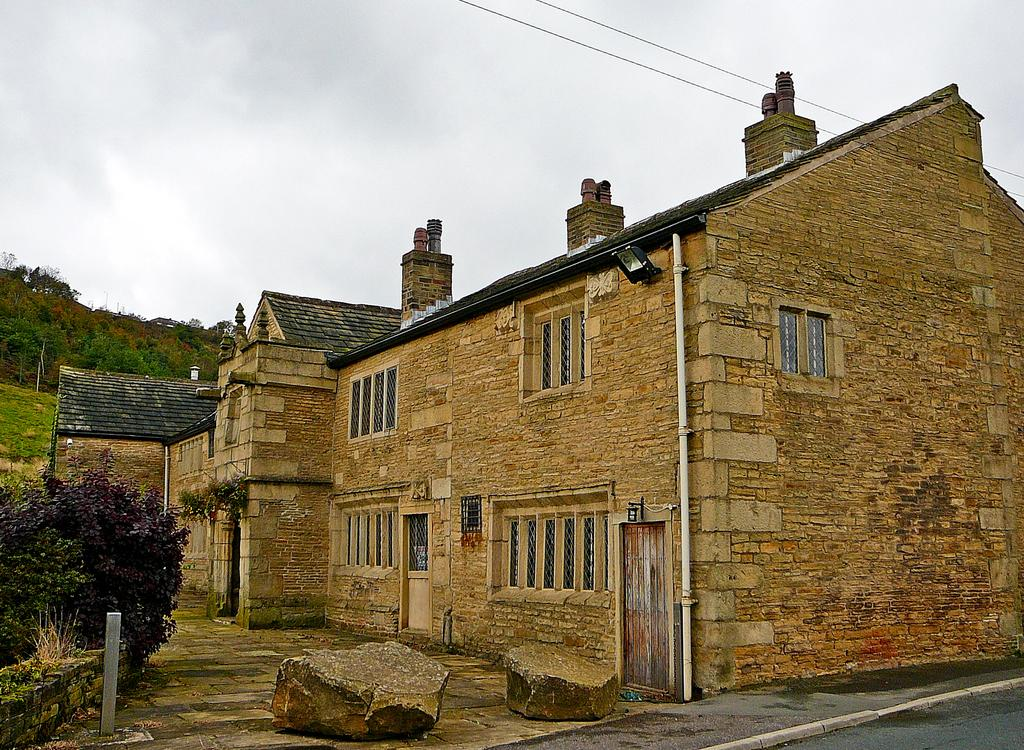What can be seen in the foreground of the image? In the foreground of the image, there are stones, a fence, trees, and a building. Can you describe the background of the image? In the background of the image, there is a mountain, the sky, and wires. When was the image taken? The image was taken during the day. What type of advertisement can be seen on the queen's dress in the image? There is no queen or advertisement present in the image. Where is the cellar located in the image? There is no mention of a cellar in the image. 